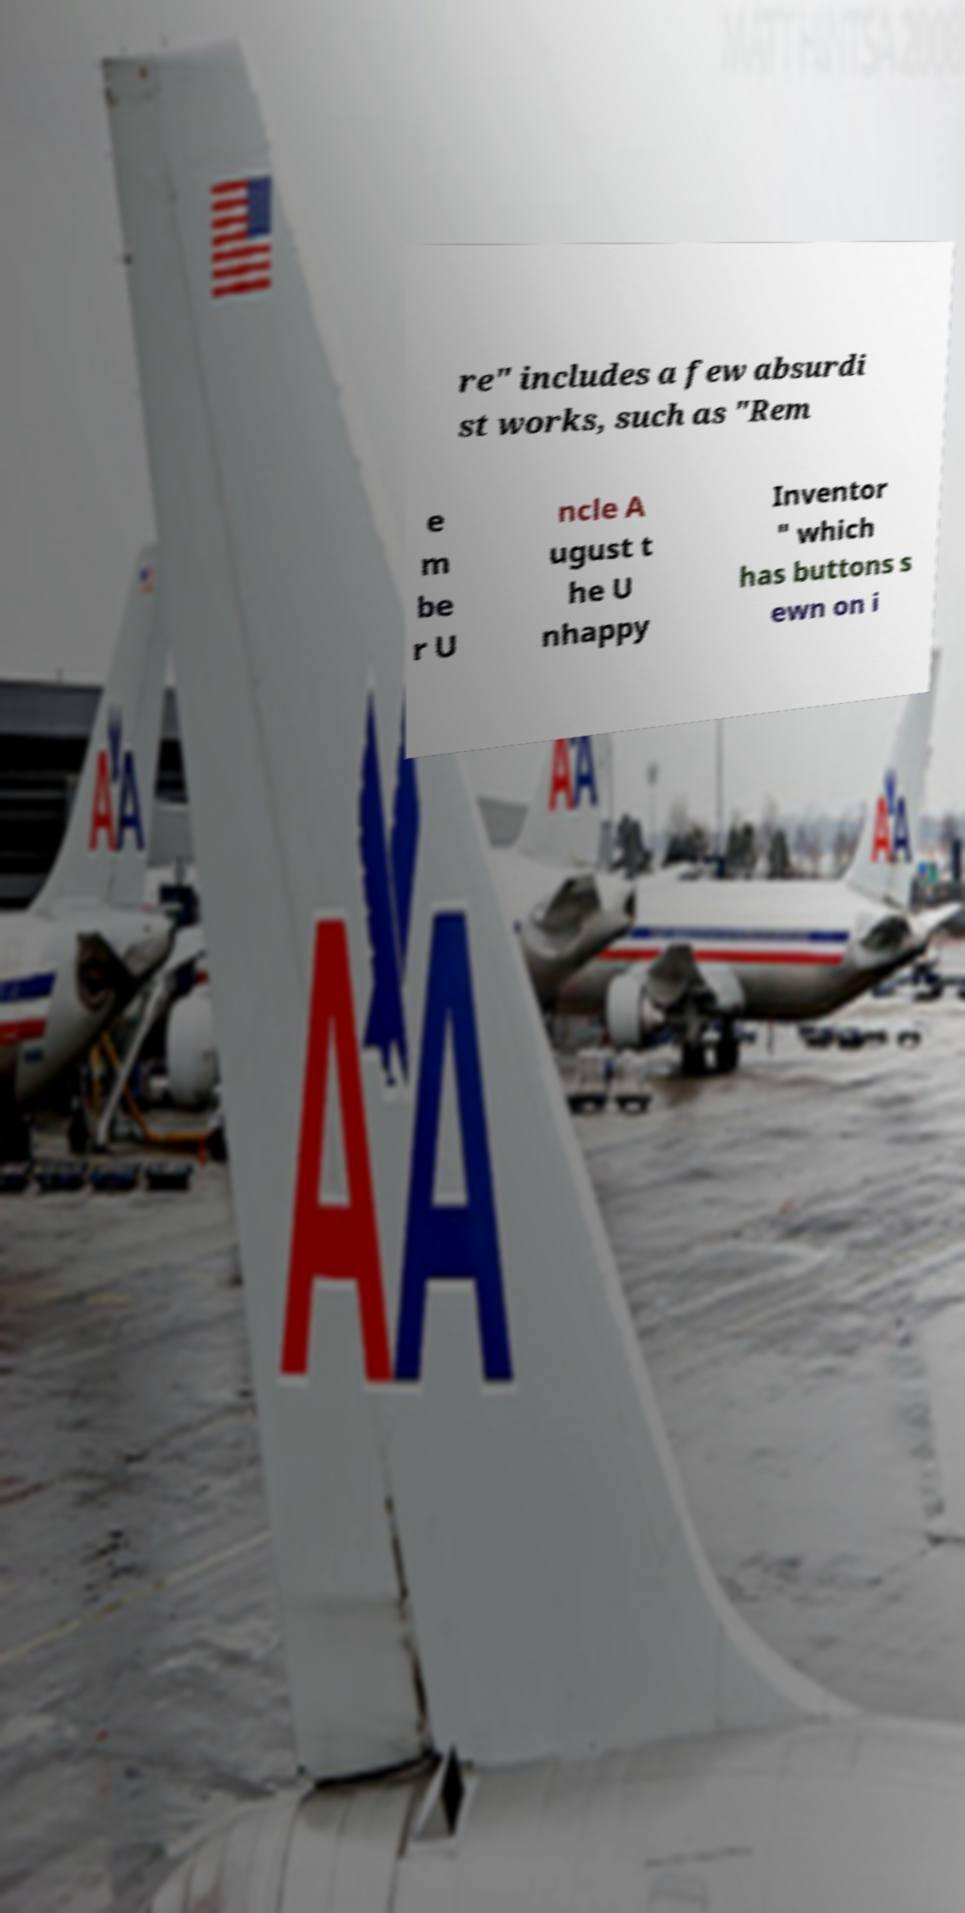Please read and relay the text visible in this image. What does it say? re" includes a few absurdi st works, such as "Rem e m be r U ncle A ugust t he U nhappy Inventor " which has buttons s ewn on i 